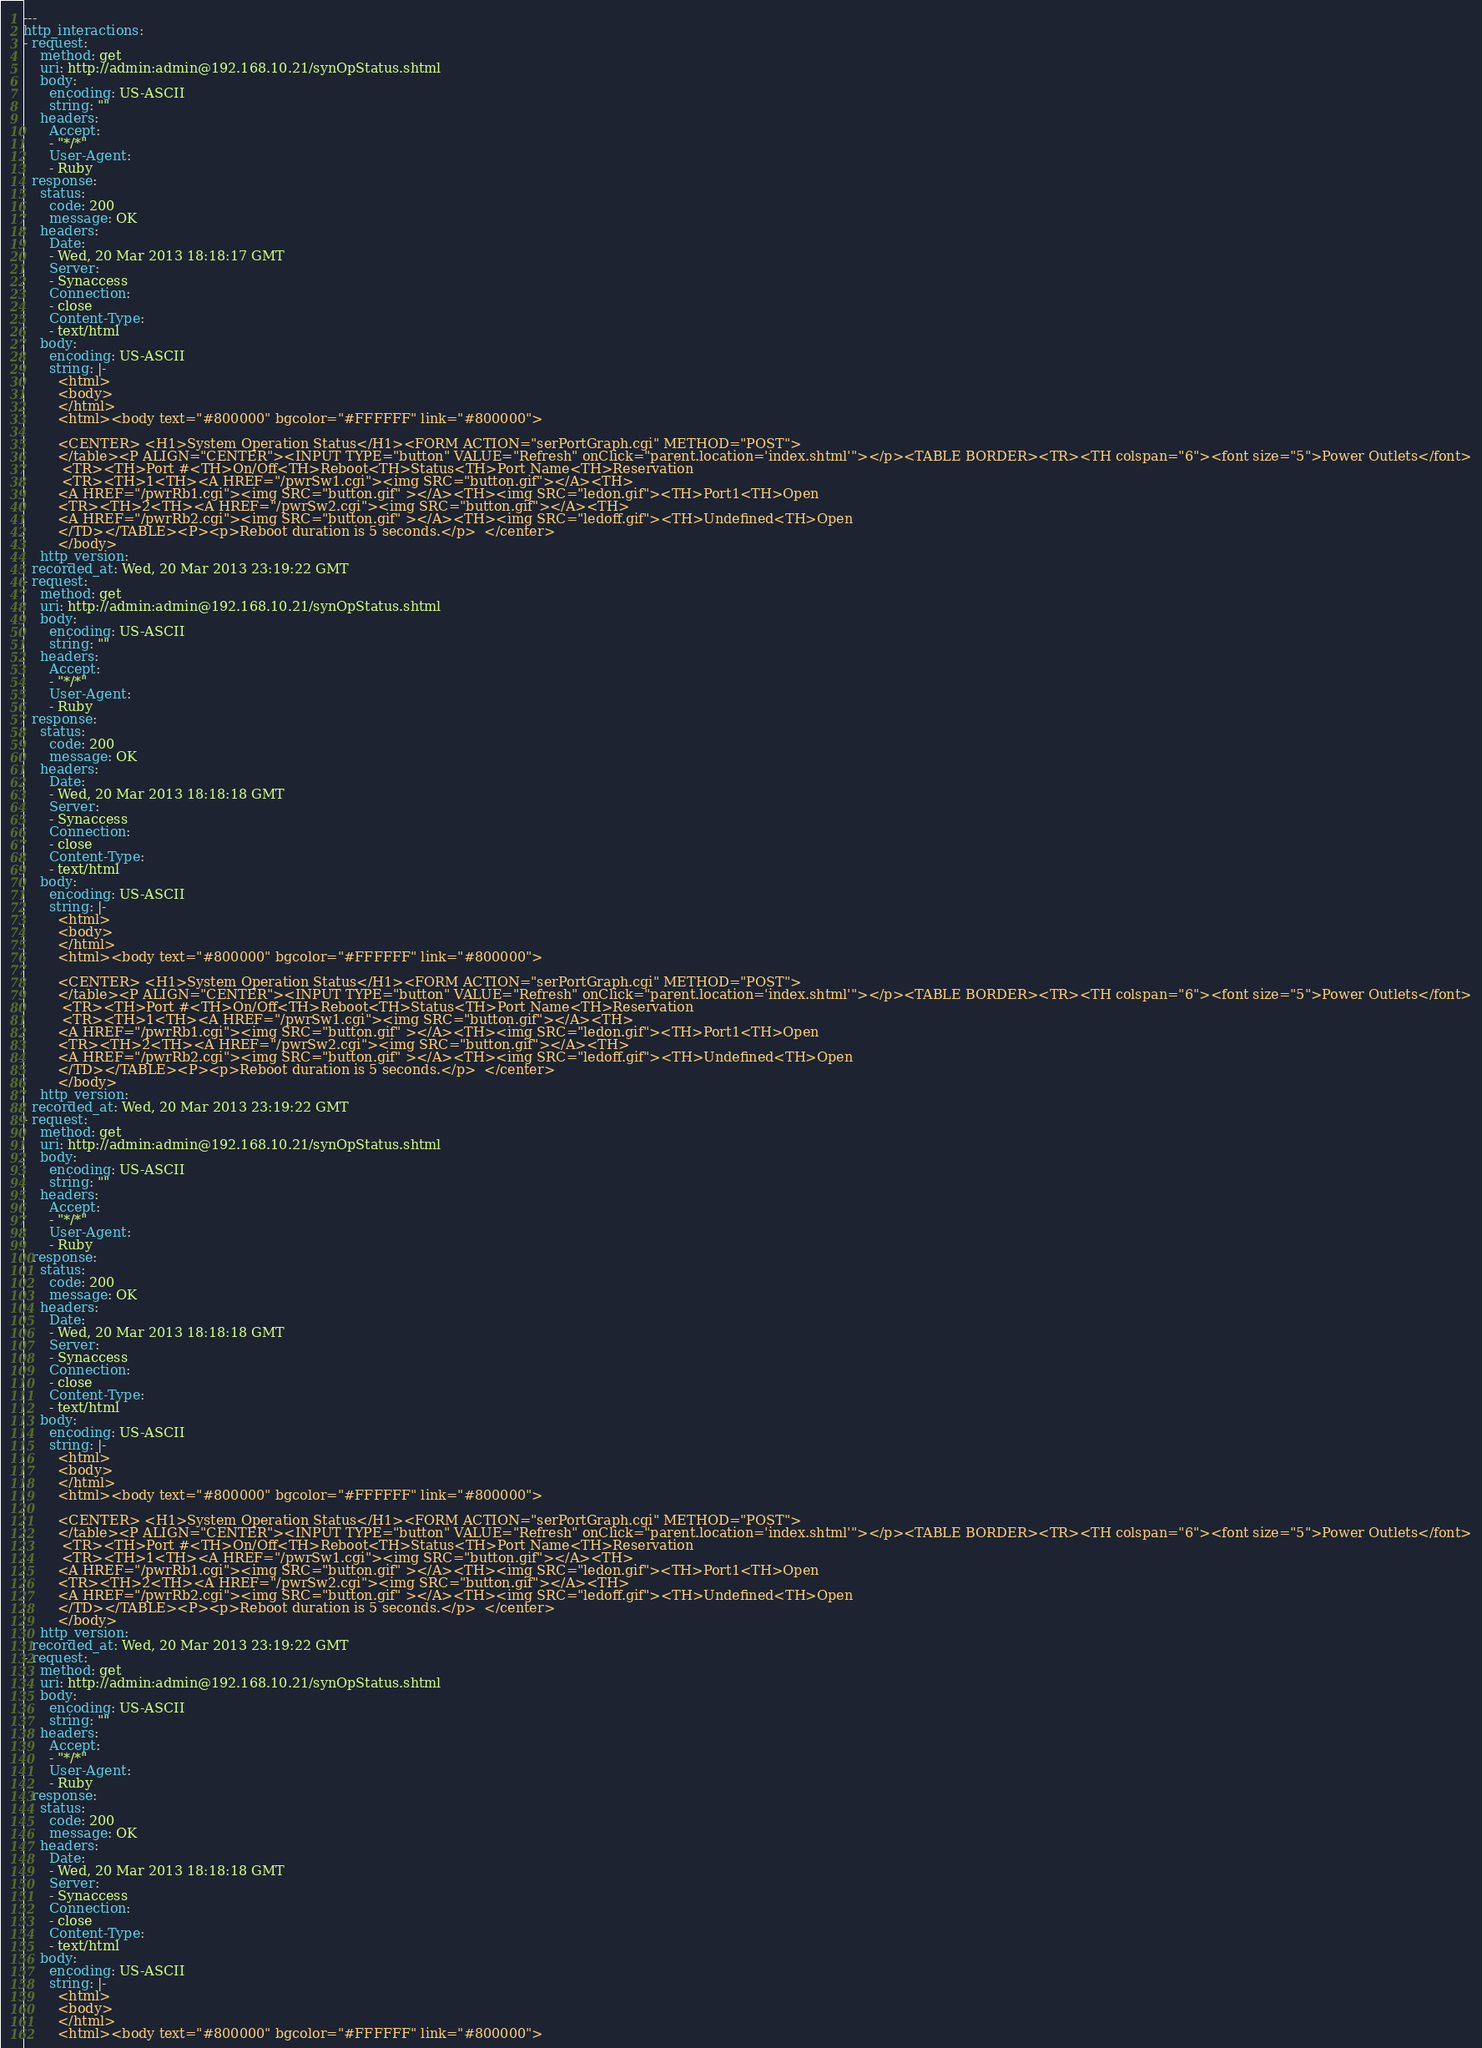Convert code to text. <code><loc_0><loc_0><loc_500><loc_500><_YAML_>---
http_interactions:
- request:
    method: get
    uri: http://admin:admin@192.168.10.21/synOpStatus.shtml
    body:
      encoding: US-ASCII
      string: ""
    headers:
      Accept:
      - "*/*"
      User-Agent:
      - Ruby
  response:
    status:
      code: 200
      message: OK
    headers:
      Date:
      - Wed, 20 Mar 2013 18:18:17 GMT
      Server:
      - Synaccess
      Connection:
      - close
      Content-Type:
      - text/html
    body:
      encoding: US-ASCII
      string: |-
        <html>
        <body>
        </html>
        <html><body text="#800000" bgcolor="#FFFFFF" link="#800000">

        <CENTER> <H1>System Operation Status</H1><FORM ACTION="serPortGraph.cgi" METHOD="POST">
        </table><P ALIGN="CENTER"><INPUT TYPE="button" VALUE="Refresh" onClick="parent.location='index.shtml'"></p><TABLE BORDER><TR><TH colspan="6"><font size="5">Power Outlets</font>
         <TR><TH>Port #<TH>On/Off<TH>Reboot<TH>Status<TH>Port Name<TH>Reservation
         <TR><TH>1<TH><A HREF="/pwrSw1.cgi"><img SRC="button.gif"></A><TH>
        <A HREF="/pwrRb1.cgi"><img SRC="button.gif" ></A><TH><img SRC="ledon.gif"><TH>Port1<TH>Open
        <TR><TH>2<TH><A HREF="/pwrSw2.cgi"><img SRC="button.gif"></A><TH>
        <A HREF="/pwrRb2.cgi"><img SRC="button.gif" ></A><TH><img SRC="ledoff.gif"><TH>Undefined<TH>Open
        </TD></TABLE><P><p>Reboot duration is 5 seconds.</p>  </center>
        </body>
    http_version:
  recorded_at: Wed, 20 Mar 2013 23:19:22 GMT
- request:
    method: get
    uri: http://admin:admin@192.168.10.21/synOpStatus.shtml
    body:
      encoding: US-ASCII
      string: ""
    headers:
      Accept:
      - "*/*"
      User-Agent:
      - Ruby
  response:
    status:
      code: 200
      message: OK
    headers:
      Date:
      - Wed, 20 Mar 2013 18:18:18 GMT
      Server:
      - Synaccess
      Connection:
      - close
      Content-Type:
      - text/html
    body:
      encoding: US-ASCII
      string: |-
        <html>
        <body>
        </html>
        <html><body text="#800000" bgcolor="#FFFFFF" link="#800000">

        <CENTER> <H1>System Operation Status</H1><FORM ACTION="serPortGraph.cgi" METHOD="POST">
        </table><P ALIGN="CENTER"><INPUT TYPE="button" VALUE="Refresh" onClick="parent.location='index.shtml'"></p><TABLE BORDER><TR><TH colspan="6"><font size="5">Power Outlets</font>
         <TR><TH>Port #<TH>On/Off<TH>Reboot<TH>Status<TH>Port Name<TH>Reservation
         <TR><TH>1<TH><A HREF="/pwrSw1.cgi"><img SRC="button.gif"></A><TH>
        <A HREF="/pwrRb1.cgi"><img SRC="button.gif" ></A><TH><img SRC="ledon.gif"><TH>Port1<TH>Open
        <TR><TH>2<TH><A HREF="/pwrSw2.cgi"><img SRC="button.gif"></A><TH>
        <A HREF="/pwrRb2.cgi"><img SRC="button.gif" ></A><TH><img SRC="ledoff.gif"><TH>Undefined<TH>Open
        </TD></TABLE><P><p>Reboot duration is 5 seconds.</p>  </center>
        </body>
    http_version:
  recorded_at: Wed, 20 Mar 2013 23:19:22 GMT
- request:
    method: get
    uri: http://admin:admin@192.168.10.21/synOpStatus.shtml
    body:
      encoding: US-ASCII
      string: ""
    headers:
      Accept:
      - "*/*"
      User-Agent:
      - Ruby
  response:
    status:
      code: 200
      message: OK
    headers:
      Date:
      - Wed, 20 Mar 2013 18:18:18 GMT
      Server:
      - Synaccess
      Connection:
      - close
      Content-Type:
      - text/html
    body:
      encoding: US-ASCII
      string: |-
        <html>
        <body>
        </html>
        <html><body text="#800000" bgcolor="#FFFFFF" link="#800000">

        <CENTER> <H1>System Operation Status</H1><FORM ACTION="serPortGraph.cgi" METHOD="POST">
        </table><P ALIGN="CENTER"><INPUT TYPE="button" VALUE="Refresh" onClick="parent.location='index.shtml'"></p><TABLE BORDER><TR><TH colspan="6"><font size="5">Power Outlets</font>
         <TR><TH>Port #<TH>On/Off<TH>Reboot<TH>Status<TH>Port Name<TH>Reservation
         <TR><TH>1<TH><A HREF="/pwrSw1.cgi"><img SRC="button.gif"></A><TH>
        <A HREF="/pwrRb1.cgi"><img SRC="button.gif" ></A><TH><img SRC="ledon.gif"><TH>Port1<TH>Open
        <TR><TH>2<TH><A HREF="/pwrSw2.cgi"><img SRC="button.gif"></A><TH>
        <A HREF="/pwrRb2.cgi"><img SRC="button.gif" ></A><TH><img SRC="ledoff.gif"><TH>Undefined<TH>Open
        </TD></TABLE><P><p>Reboot duration is 5 seconds.</p>  </center>
        </body>
    http_version:
  recorded_at: Wed, 20 Mar 2013 23:19:22 GMT
- request:
    method: get
    uri: http://admin:admin@192.168.10.21/synOpStatus.shtml
    body:
      encoding: US-ASCII
      string: ""
    headers:
      Accept:
      - "*/*"
      User-Agent:
      - Ruby
  response:
    status:
      code: 200
      message: OK
    headers:
      Date:
      - Wed, 20 Mar 2013 18:18:18 GMT
      Server:
      - Synaccess
      Connection:
      - close
      Content-Type:
      - text/html
    body:
      encoding: US-ASCII
      string: |-
        <html>
        <body>
        </html>
        <html><body text="#800000" bgcolor="#FFFFFF" link="#800000">
</code> 